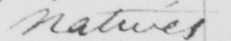Transcribe the text shown in this historical manuscript line. natives 